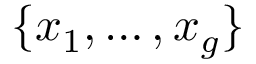Convert formula to latex. <formula><loc_0><loc_0><loc_500><loc_500>\{ x _ { 1 } , \dots , x _ { g } \}</formula> 